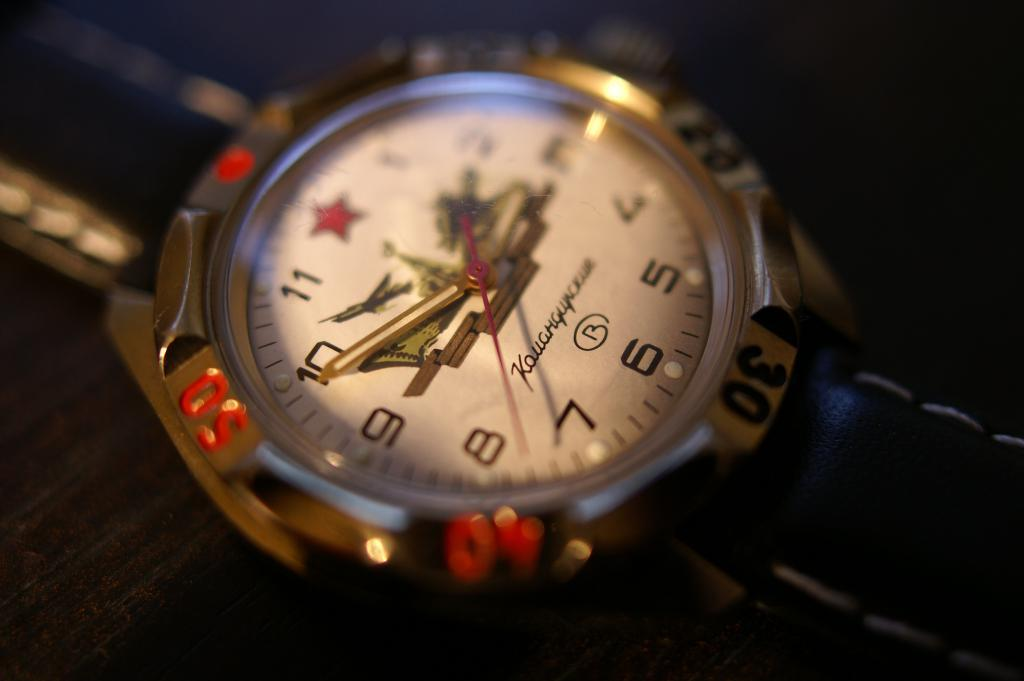Provide a one-sentence caption for the provided image. A watch with a brand name that starts with K has a red star instead of the number 12 on it. 